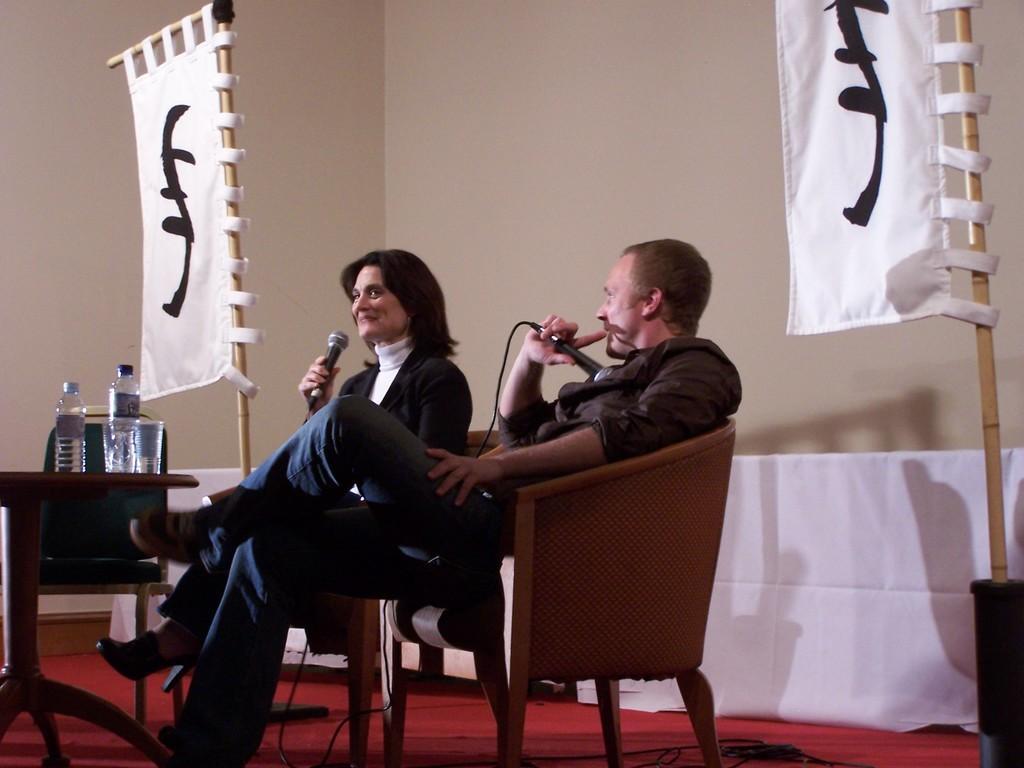Please provide a concise description of this image. In this picture there is a conference going on. In the center of the picture there are chairs, people, mics, table, bottles, glasses, banners and other object. In the background there is a white color curtain and a wall painted white. 